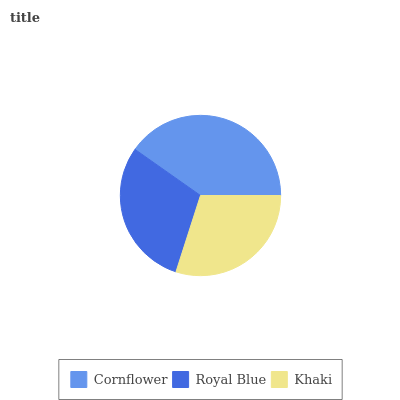Is Royal Blue the minimum?
Answer yes or no. Yes. Is Cornflower the maximum?
Answer yes or no. Yes. Is Khaki the minimum?
Answer yes or no. No. Is Khaki the maximum?
Answer yes or no. No. Is Khaki greater than Royal Blue?
Answer yes or no. Yes. Is Royal Blue less than Khaki?
Answer yes or no. Yes. Is Royal Blue greater than Khaki?
Answer yes or no. No. Is Khaki less than Royal Blue?
Answer yes or no. No. Is Khaki the high median?
Answer yes or no. Yes. Is Khaki the low median?
Answer yes or no. Yes. Is Cornflower the high median?
Answer yes or no. No. Is Cornflower the low median?
Answer yes or no. No. 